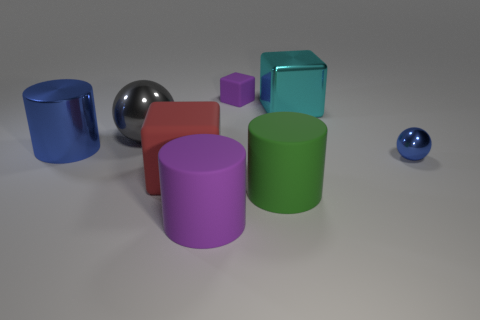What is the color of the other tiny thing that is the same material as the green thing?
Give a very brief answer. Purple. How many shiny objects are either red blocks or balls?
Ensure brevity in your answer.  2. There is a purple rubber thing that is the same size as the gray ball; what shape is it?
Keep it short and to the point. Cylinder. What number of objects are either cubes that are behind the big green cylinder or big matte cylinders that are in front of the big green rubber thing?
Ensure brevity in your answer.  4. There is a gray ball that is the same size as the purple rubber cylinder; what is it made of?
Offer a very short reply. Metal. What number of other things are made of the same material as the red object?
Your answer should be very brief. 3. Is the number of blue metal objects in front of the tiny sphere the same as the number of large green things that are behind the large green matte cylinder?
Offer a very short reply. Yes. What number of red things are either large matte things or rubber cubes?
Provide a succinct answer. 1. There is a small rubber block; is it the same color as the matte cylinder on the left side of the tiny matte cube?
Offer a terse response. Yes. What number of other objects are the same color as the tiny sphere?
Your response must be concise. 1. 